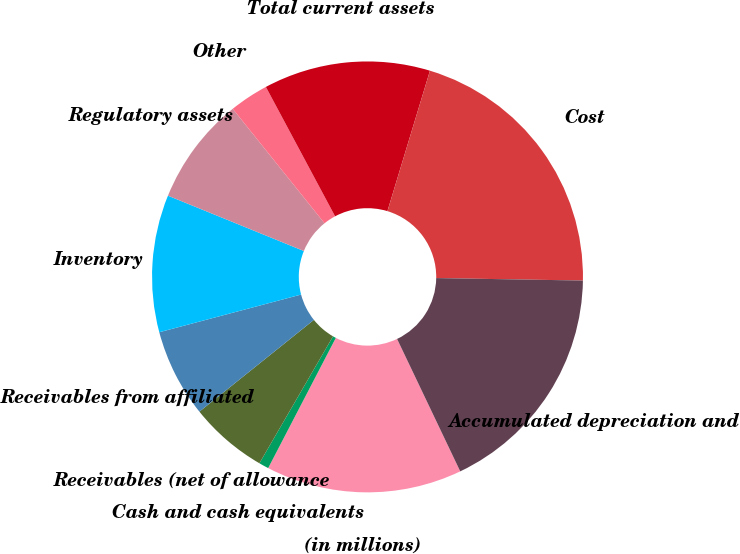<chart> <loc_0><loc_0><loc_500><loc_500><pie_chart><fcel>(in millions)<fcel>Cash and cash equivalents<fcel>Receivables (net of allowance<fcel>Receivables from affiliated<fcel>Inventory<fcel>Regulatory assets<fcel>Other<fcel>Total current assets<fcel>Cost<fcel>Accumulated depreciation and<nl><fcel>14.71%<fcel>0.74%<fcel>5.88%<fcel>6.62%<fcel>10.29%<fcel>8.09%<fcel>2.94%<fcel>12.5%<fcel>20.59%<fcel>17.65%<nl></chart> 